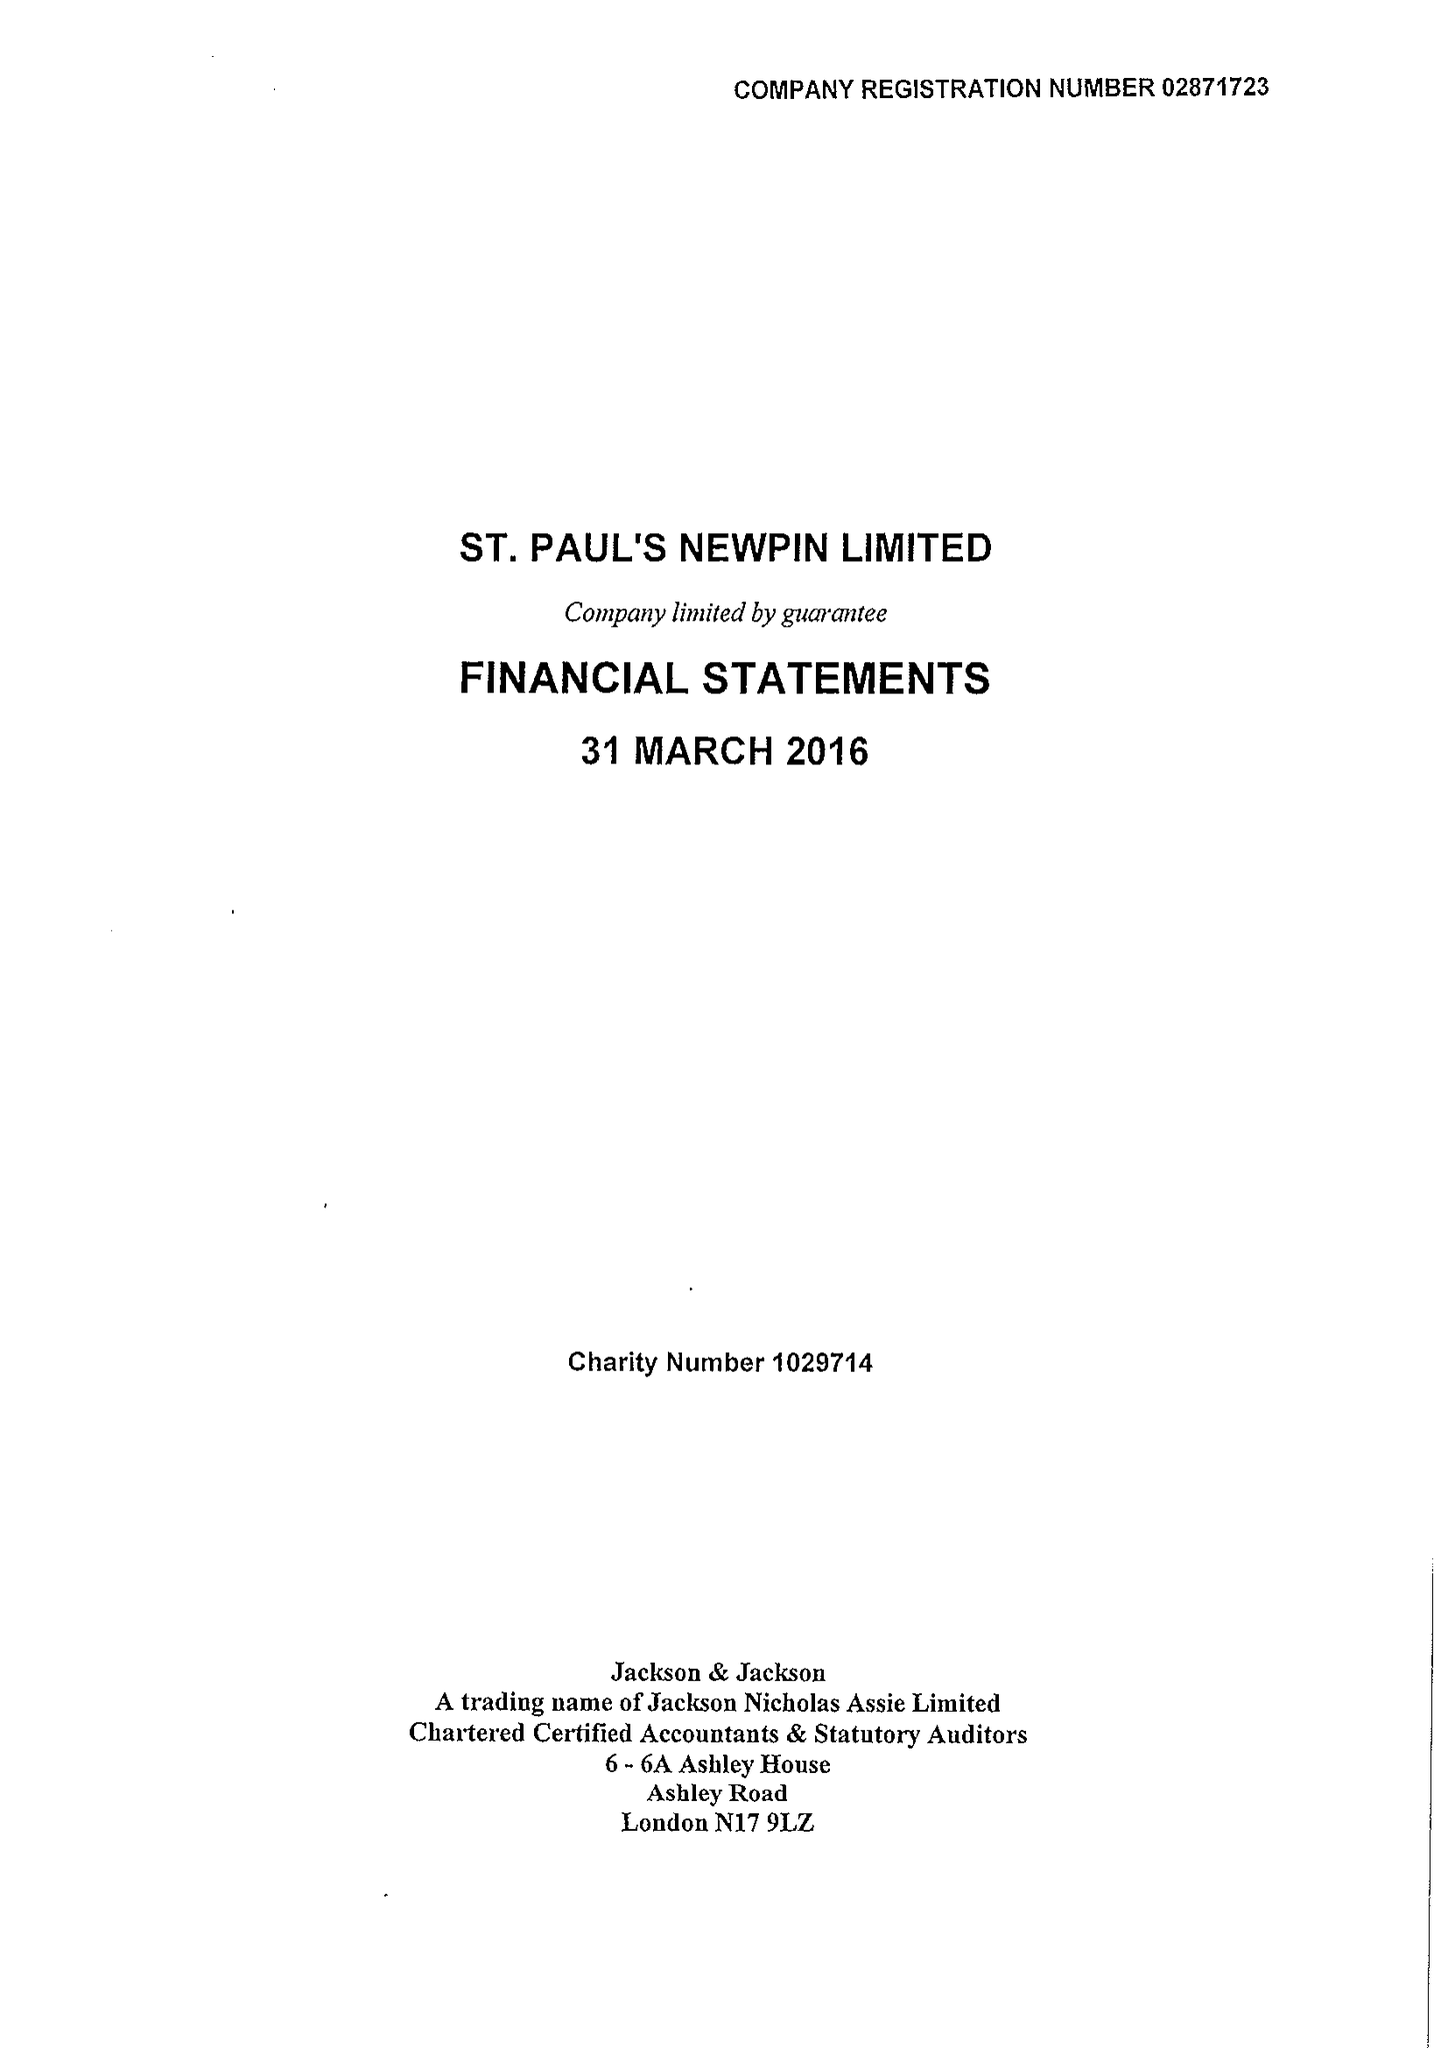What is the value for the address__postcode?
Answer the question using a single word or phrase. NW8 8EQ 